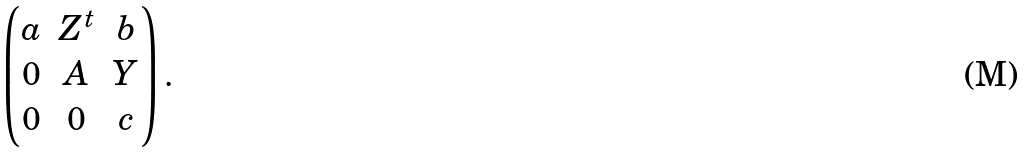Convert formula to latex. <formula><loc_0><loc_0><loc_500><loc_500>\begin{pmatrix} a & Z ^ { t } & b \\ 0 & A & Y \\ 0 & 0 & c \end{pmatrix} .</formula> 